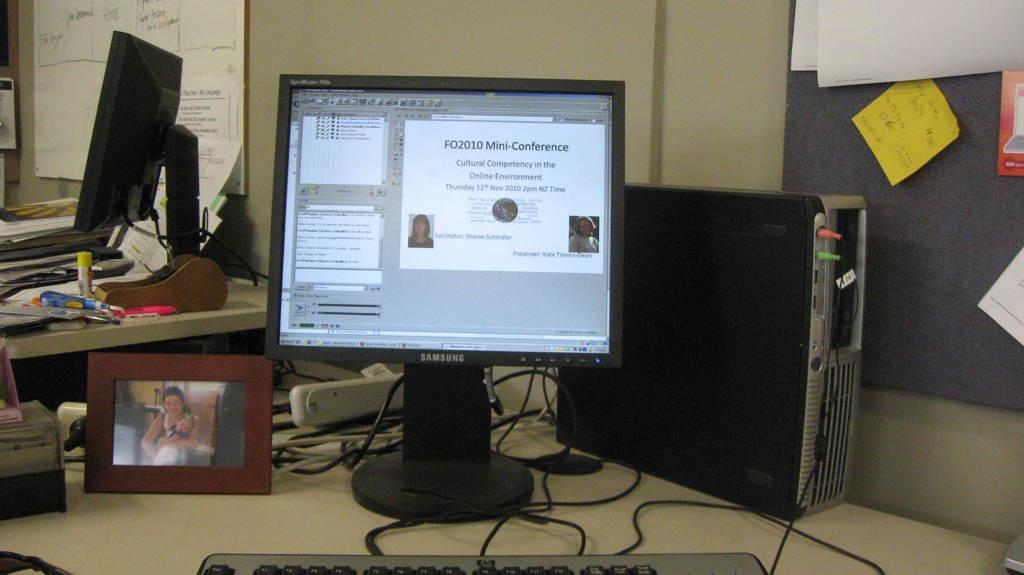<image>
Write a terse but informative summary of the picture. A computer screen has a window with information about a Mini-Conference on it. 